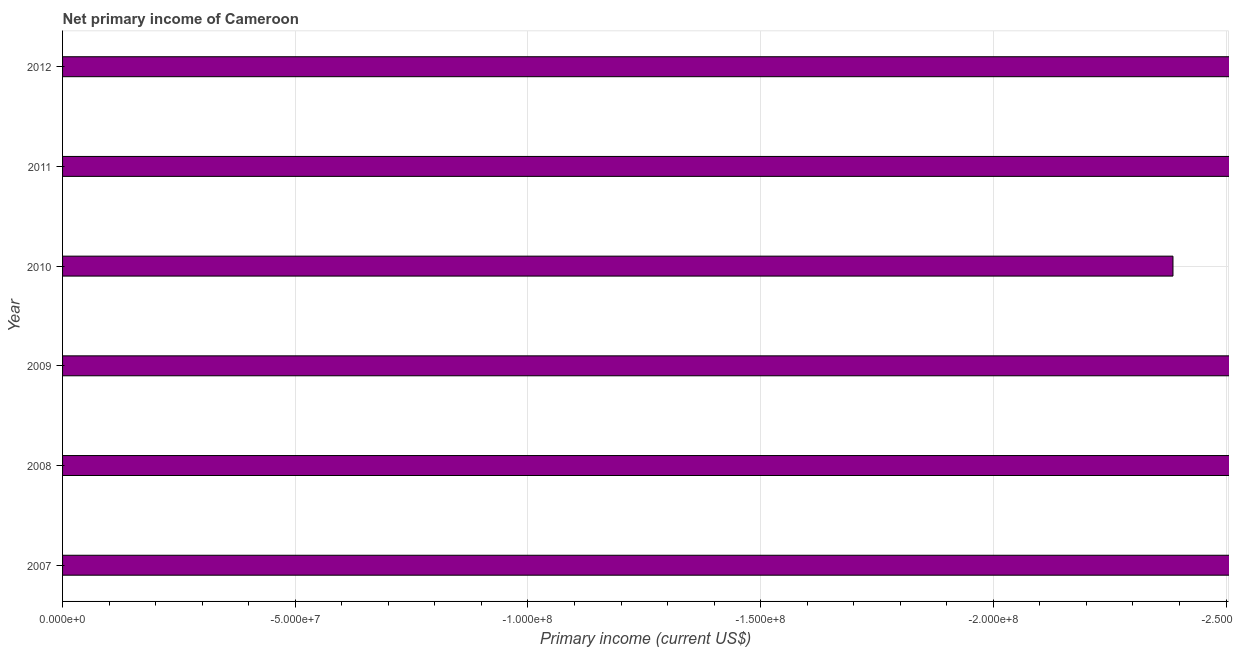Does the graph contain any zero values?
Your response must be concise. Yes. Does the graph contain grids?
Ensure brevity in your answer.  Yes. What is the title of the graph?
Make the answer very short. Net primary income of Cameroon. What is the label or title of the X-axis?
Give a very brief answer. Primary income (current US$). What is the amount of primary income in 2008?
Ensure brevity in your answer.  0. What is the sum of the amount of primary income?
Your response must be concise. 0. What is the median amount of primary income?
Offer a terse response. 0. How many years are there in the graph?
Provide a short and direct response. 6. What is the difference between two consecutive major ticks on the X-axis?
Ensure brevity in your answer.  5.00e+07. What is the Primary income (current US$) in 2007?
Your response must be concise. 0. What is the Primary income (current US$) of 2012?
Your answer should be compact. 0. 